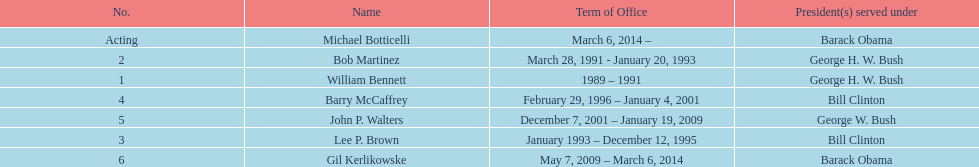How many directors served more than 3 years? 3. 